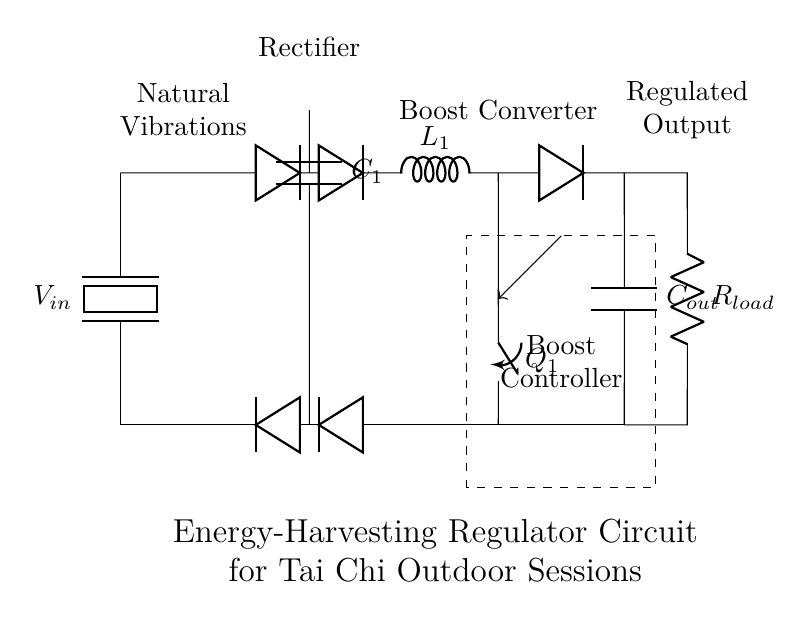What is the input source of this circuit? The circuit uses a piezoelectric element as the energy harvesting source, indicated on the left side of the diagram.
Answer: Piezoelectric What component is responsible for voltage regulation? The boost converter, represented in the circuit, regulates and increases the output voltage for efficient energy use.
Answer: Boost converter What is the function of the rectifier in this circuit? The rectifier's role is to convert the alternating current from the piezoelectric source into direct current, allowing the subsequent components to process it correctly.
Answer: To convert AC to DC How many capacitors are present in this circuit? There are two capacitors; one labeled as C1 in the rectifier section and the other as C_out in the output section.
Answer: Two What is the purpose of the switch labeled Q1? The switch Q1 is used to control the flow of current within the boost converter circuit, helping to regulate the voltage output effectively.
Answer: Control current flow What does the label "Natural Vibrations" signify in this circuit? The label indicates that the energy harvesting component (the piezoelectric) gains energy from the vibrations occurring due to outdoor tai chi sessions, which creates a source of mechanical energy.
Answer: Energy source What type of load does this regulator circuit support? The load in this circuit is in the form of a resistor, which is represented by the component labeled R_load, indicating that the circuit can supply power to resistive loads.
Answer: Resistor load 